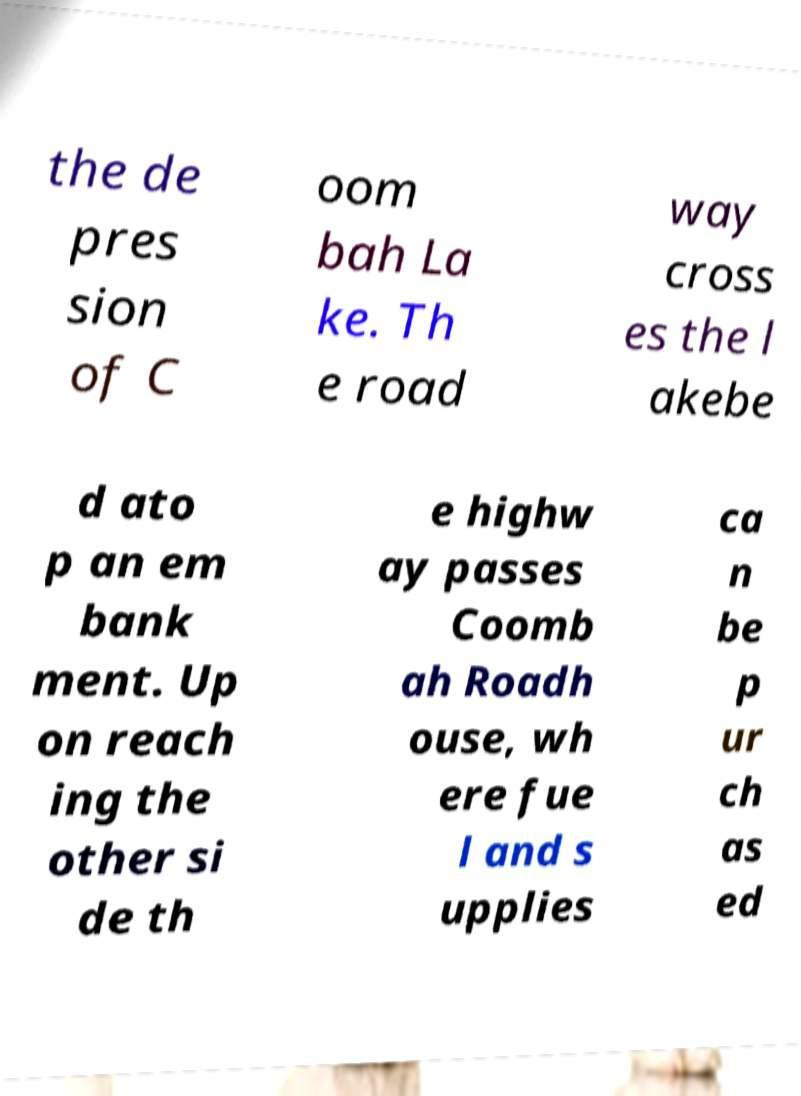For documentation purposes, I need the text within this image transcribed. Could you provide that? the de pres sion of C oom bah La ke. Th e road way cross es the l akebe d ato p an em bank ment. Up on reach ing the other si de th e highw ay passes Coomb ah Roadh ouse, wh ere fue l and s upplies ca n be p ur ch as ed 